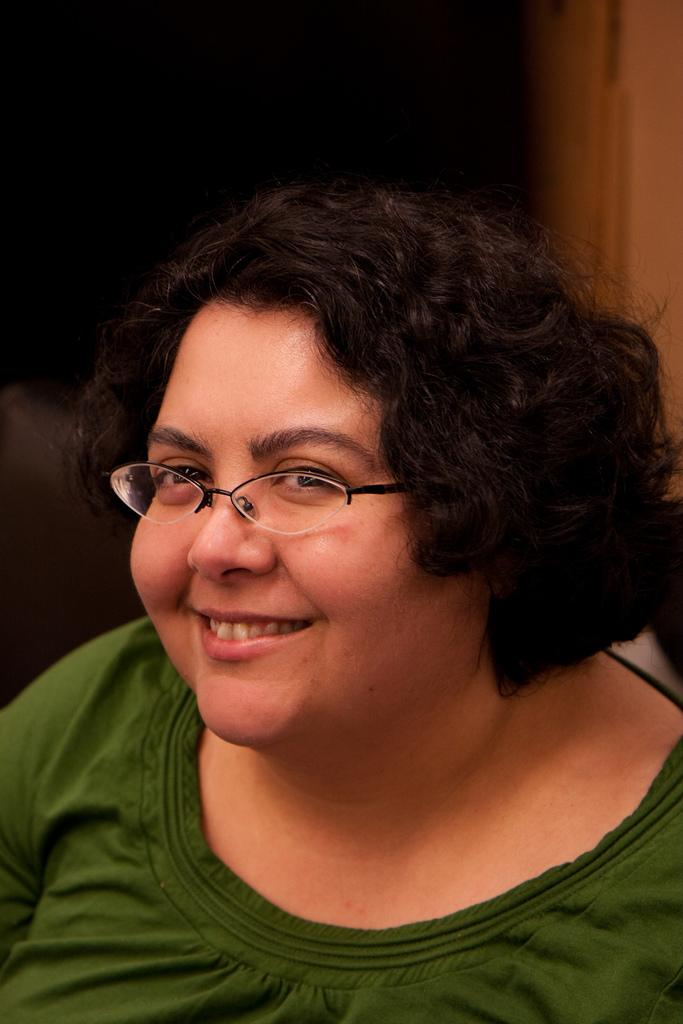Who is the main subject in the foreground of the image? There is a woman in the foreground of the image. What is the woman wearing on her face? The woman is wearing spectacles. What is the woman's facial expression in the image? The woman is smiling. What type of transport is the woman using in the image? There is no transport visible in the image; it only features a woman in the foreground. Can you tell me if the woman is talking to a stranger in the image? There is no indication of any other person in the image, so it cannot be determined if the woman is talking to a stranger. 